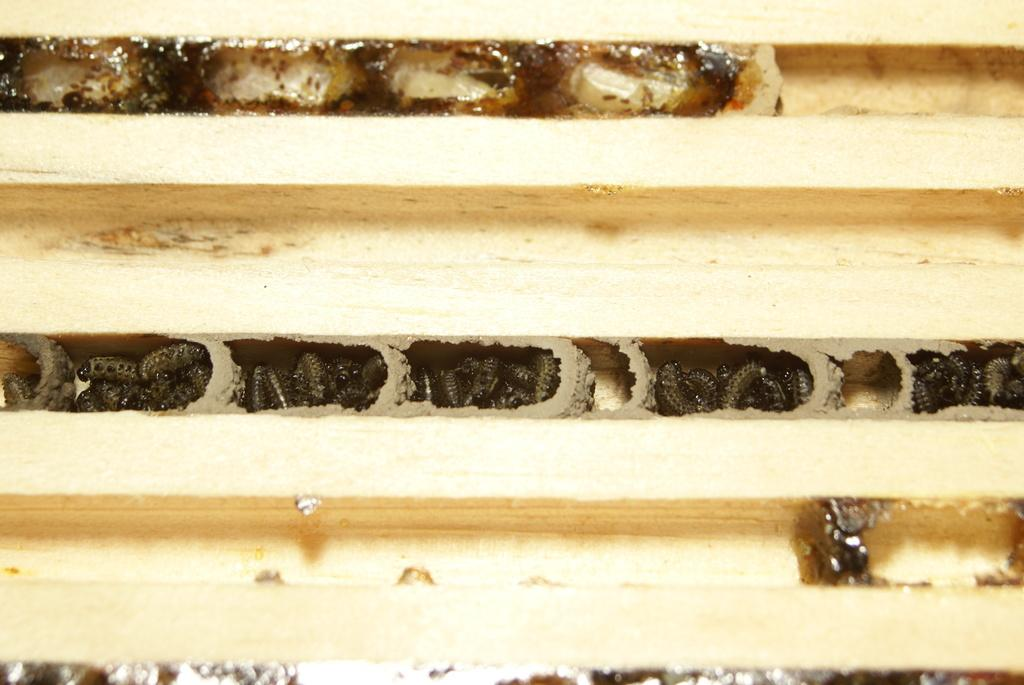What type of creatures can be seen in the image? There are insects in the image. Where are the insects located? The insects are in the small gaps of a wooden object. What is the desire of the minister in the image? There is no minister present in the image, as it only features insects in the small gaps of a wooden object. 